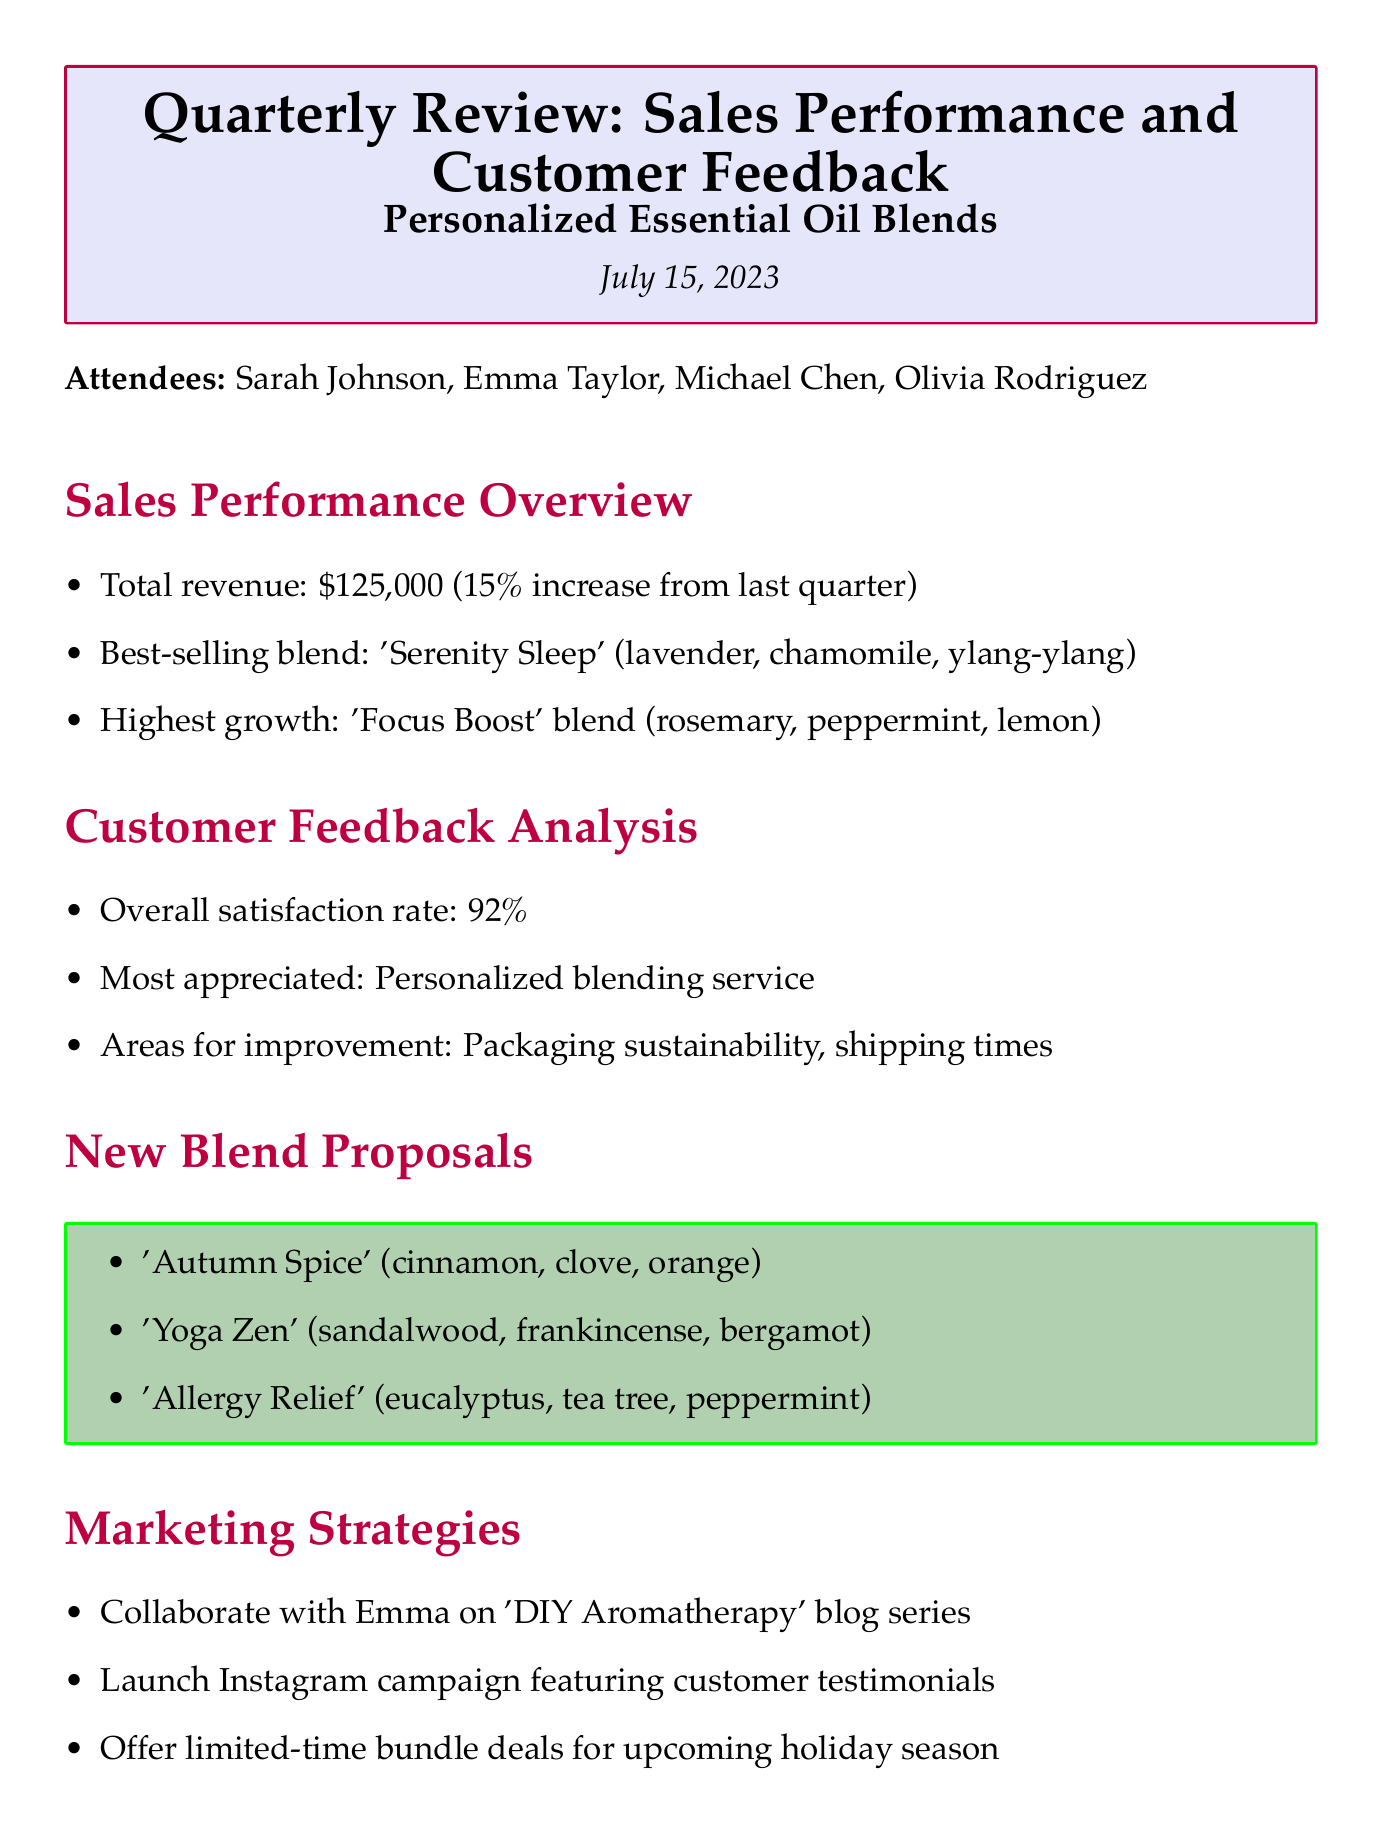what is the date of the meeting? The date of the meeting is clearly stated in the document as July 15, 2023.
Answer: July 15, 2023 who is the best-selling blend named after? The best-selling blend is 'Serenity Sleep', which is composed of lavender, chamomile, and ylang-ylang as detailed in the sales performance overview.
Answer: 'Serenity Sleep' what was the overall satisfaction rate? According to the customer feedback analysis section, the overall satisfaction rate is provided as a percentage.
Answer: 92% which blend showed the highest growth? The document specifies 'Focus Boost' blend as the one with the highest growth in the sales performance overview.
Answer: 'Focus Boost' what are the proposed new blends? The section on new blend proposals lists three specific blends that were suggested during the meeting.
Answer: 'Autumn Spice', 'Yoga Zen', 'Allergy Relief' who is responsible for drafting the blog content calendar? The action items clearly delegate the task of drafting the blog content calendar to Emma.
Answer: Emma what area needs improvement according to customer feedback? The document highlights packaging sustainability and shipping times as areas that require attention based on customer feedback.
Answer: Packaging sustainability and shipping times what marketing strategy involves Instagram? The marketing strategies include launching an Instagram campaign featuring customer testimonials as a promotional tactic.
Answer: Launch Instagram campaign featuring customer testimonials 